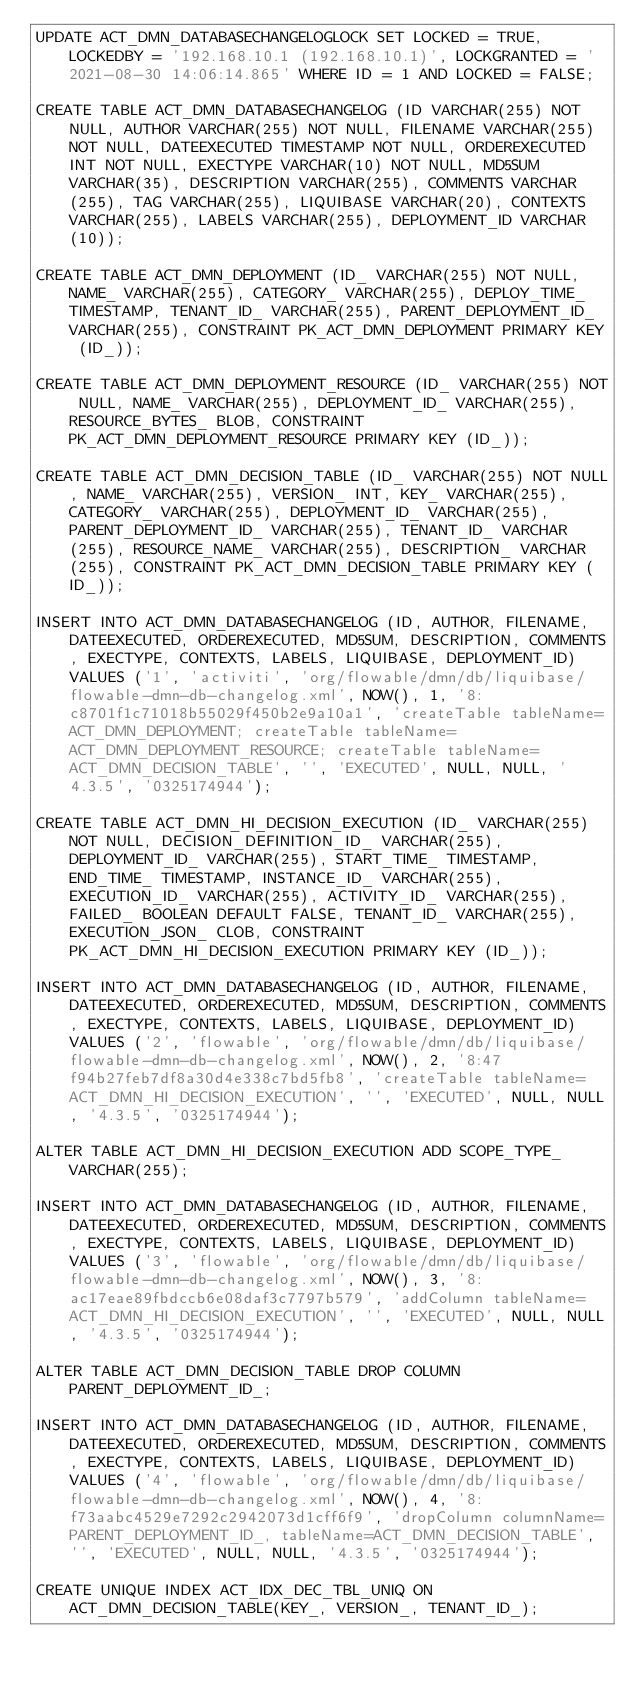<code> <loc_0><loc_0><loc_500><loc_500><_SQL_>UPDATE ACT_DMN_DATABASECHANGELOGLOCK SET LOCKED = TRUE, LOCKEDBY = '192.168.10.1 (192.168.10.1)', LOCKGRANTED = '2021-08-30 14:06:14.865' WHERE ID = 1 AND LOCKED = FALSE;

CREATE TABLE ACT_DMN_DATABASECHANGELOG (ID VARCHAR(255) NOT NULL, AUTHOR VARCHAR(255) NOT NULL, FILENAME VARCHAR(255) NOT NULL, DATEEXECUTED TIMESTAMP NOT NULL, ORDEREXECUTED INT NOT NULL, EXECTYPE VARCHAR(10) NOT NULL, MD5SUM VARCHAR(35), DESCRIPTION VARCHAR(255), COMMENTS VARCHAR(255), TAG VARCHAR(255), LIQUIBASE VARCHAR(20), CONTEXTS VARCHAR(255), LABELS VARCHAR(255), DEPLOYMENT_ID VARCHAR(10));

CREATE TABLE ACT_DMN_DEPLOYMENT (ID_ VARCHAR(255) NOT NULL, NAME_ VARCHAR(255), CATEGORY_ VARCHAR(255), DEPLOY_TIME_ TIMESTAMP, TENANT_ID_ VARCHAR(255), PARENT_DEPLOYMENT_ID_ VARCHAR(255), CONSTRAINT PK_ACT_DMN_DEPLOYMENT PRIMARY KEY (ID_));

CREATE TABLE ACT_DMN_DEPLOYMENT_RESOURCE (ID_ VARCHAR(255) NOT NULL, NAME_ VARCHAR(255), DEPLOYMENT_ID_ VARCHAR(255), RESOURCE_BYTES_ BLOB, CONSTRAINT PK_ACT_DMN_DEPLOYMENT_RESOURCE PRIMARY KEY (ID_));

CREATE TABLE ACT_DMN_DECISION_TABLE (ID_ VARCHAR(255) NOT NULL, NAME_ VARCHAR(255), VERSION_ INT, KEY_ VARCHAR(255), CATEGORY_ VARCHAR(255), DEPLOYMENT_ID_ VARCHAR(255), PARENT_DEPLOYMENT_ID_ VARCHAR(255), TENANT_ID_ VARCHAR(255), RESOURCE_NAME_ VARCHAR(255), DESCRIPTION_ VARCHAR(255), CONSTRAINT PK_ACT_DMN_DECISION_TABLE PRIMARY KEY (ID_));

INSERT INTO ACT_DMN_DATABASECHANGELOG (ID, AUTHOR, FILENAME, DATEEXECUTED, ORDEREXECUTED, MD5SUM, DESCRIPTION, COMMENTS, EXECTYPE, CONTEXTS, LABELS, LIQUIBASE, DEPLOYMENT_ID) VALUES ('1', 'activiti', 'org/flowable/dmn/db/liquibase/flowable-dmn-db-changelog.xml', NOW(), 1, '8:c8701f1c71018b55029f450b2e9a10a1', 'createTable tableName=ACT_DMN_DEPLOYMENT; createTable tableName=ACT_DMN_DEPLOYMENT_RESOURCE; createTable tableName=ACT_DMN_DECISION_TABLE', '', 'EXECUTED', NULL, NULL, '4.3.5', '0325174944');

CREATE TABLE ACT_DMN_HI_DECISION_EXECUTION (ID_ VARCHAR(255) NOT NULL, DECISION_DEFINITION_ID_ VARCHAR(255), DEPLOYMENT_ID_ VARCHAR(255), START_TIME_ TIMESTAMP, END_TIME_ TIMESTAMP, INSTANCE_ID_ VARCHAR(255), EXECUTION_ID_ VARCHAR(255), ACTIVITY_ID_ VARCHAR(255), FAILED_ BOOLEAN DEFAULT FALSE, TENANT_ID_ VARCHAR(255), EXECUTION_JSON_ CLOB, CONSTRAINT PK_ACT_DMN_HI_DECISION_EXECUTION PRIMARY KEY (ID_));

INSERT INTO ACT_DMN_DATABASECHANGELOG (ID, AUTHOR, FILENAME, DATEEXECUTED, ORDEREXECUTED, MD5SUM, DESCRIPTION, COMMENTS, EXECTYPE, CONTEXTS, LABELS, LIQUIBASE, DEPLOYMENT_ID) VALUES ('2', 'flowable', 'org/flowable/dmn/db/liquibase/flowable-dmn-db-changelog.xml', NOW(), 2, '8:47f94b27feb7df8a30d4e338c7bd5fb8', 'createTable tableName=ACT_DMN_HI_DECISION_EXECUTION', '', 'EXECUTED', NULL, NULL, '4.3.5', '0325174944');

ALTER TABLE ACT_DMN_HI_DECISION_EXECUTION ADD SCOPE_TYPE_ VARCHAR(255);

INSERT INTO ACT_DMN_DATABASECHANGELOG (ID, AUTHOR, FILENAME, DATEEXECUTED, ORDEREXECUTED, MD5SUM, DESCRIPTION, COMMENTS, EXECTYPE, CONTEXTS, LABELS, LIQUIBASE, DEPLOYMENT_ID) VALUES ('3', 'flowable', 'org/flowable/dmn/db/liquibase/flowable-dmn-db-changelog.xml', NOW(), 3, '8:ac17eae89fbdccb6e08daf3c7797b579', 'addColumn tableName=ACT_DMN_HI_DECISION_EXECUTION', '', 'EXECUTED', NULL, NULL, '4.3.5', '0325174944');

ALTER TABLE ACT_DMN_DECISION_TABLE DROP COLUMN PARENT_DEPLOYMENT_ID_;

INSERT INTO ACT_DMN_DATABASECHANGELOG (ID, AUTHOR, FILENAME, DATEEXECUTED, ORDEREXECUTED, MD5SUM, DESCRIPTION, COMMENTS, EXECTYPE, CONTEXTS, LABELS, LIQUIBASE, DEPLOYMENT_ID) VALUES ('4', 'flowable', 'org/flowable/dmn/db/liquibase/flowable-dmn-db-changelog.xml', NOW(), 4, '8:f73aabc4529e7292c2942073d1cff6f9', 'dropColumn columnName=PARENT_DEPLOYMENT_ID_, tableName=ACT_DMN_DECISION_TABLE', '', 'EXECUTED', NULL, NULL, '4.3.5', '0325174944');

CREATE UNIQUE INDEX ACT_IDX_DEC_TBL_UNIQ ON ACT_DMN_DECISION_TABLE(KEY_, VERSION_, TENANT_ID_);
</code> 